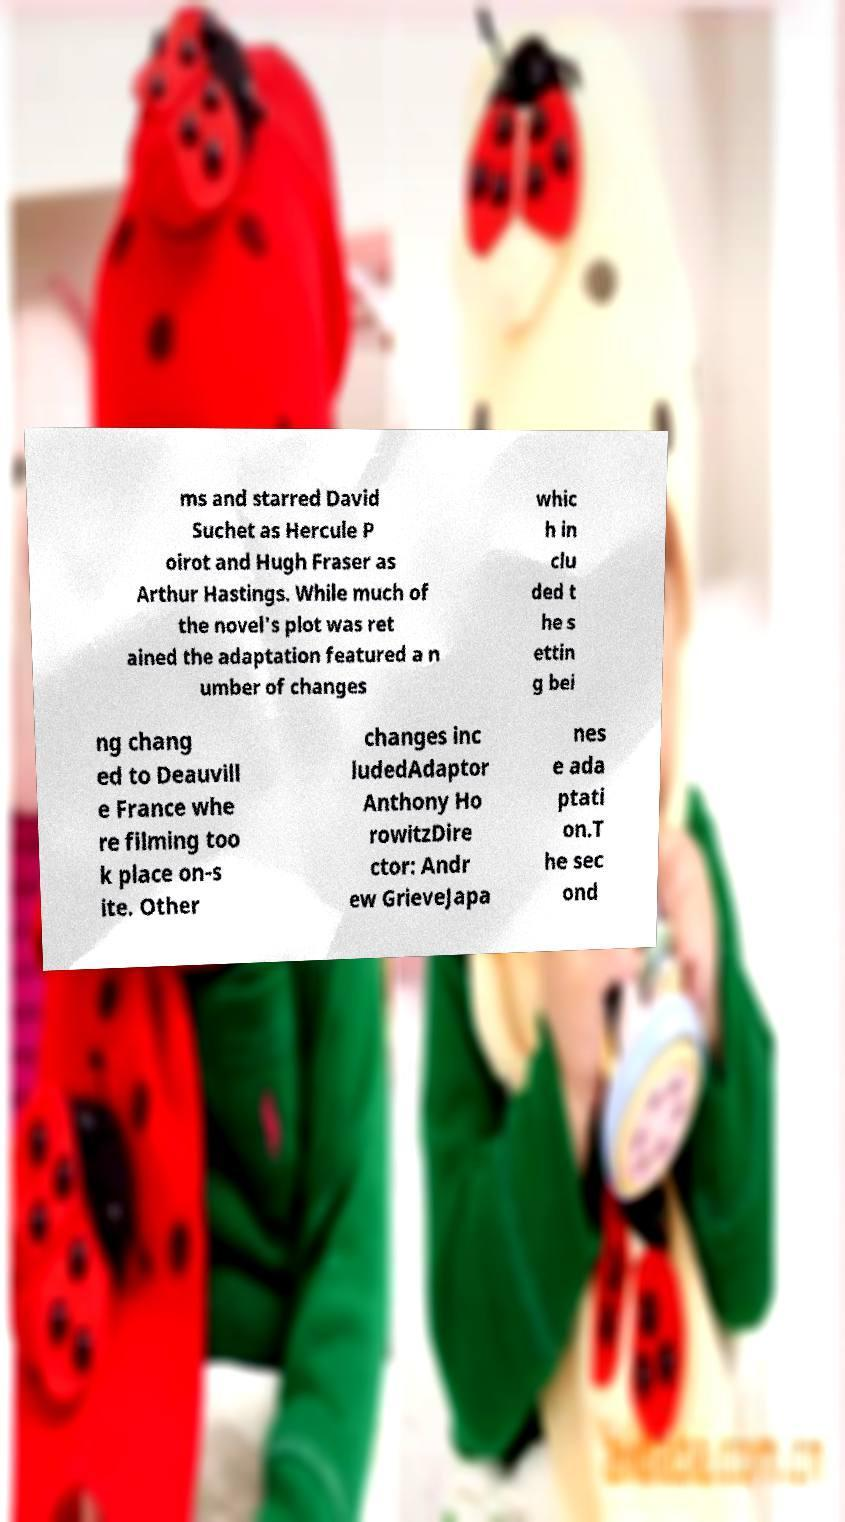Please read and relay the text visible in this image. What does it say? ms and starred David Suchet as Hercule P oirot and Hugh Fraser as Arthur Hastings. While much of the novel's plot was ret ained the adaptation featured a n umber of changes whic h in clu ded t he s ettin g bei ng chang ed to Deauvill e France whe re filming too k place on-s ite. Other changes inc ludedAdaptor Anthony Ho rowitzDire ctor: Andr ew GrieveJapa nes e ada ptati on.T he sec ond 